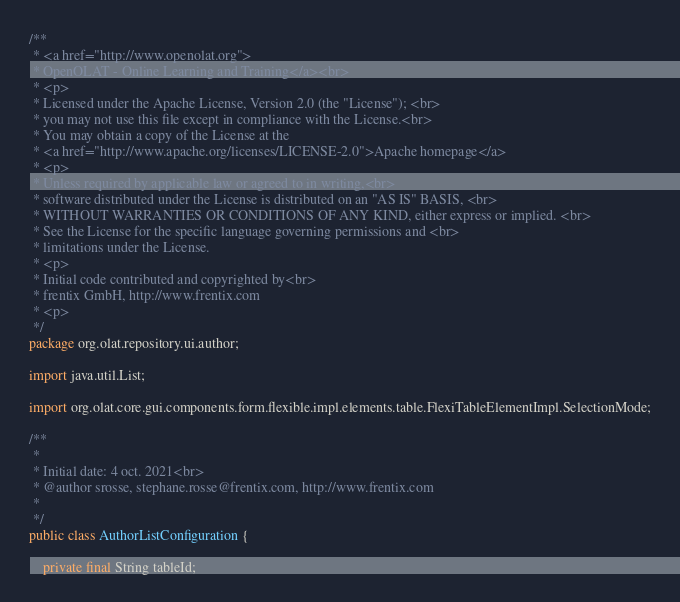Convert code to text. <code><loc_0><loc_0><loc_500><loc_500><_Java_>/**
 * <a href="http://www.openolat.org">
 * OpenOLAT - Online Learning and Training</a><br>
 * <p>
 * Licensed under the Apache License, Version 2.0 (the "License"); <br>
 * you may not use this file except in compliance with the License.<br>
 * You may obtain a copy of the License at the
 * <a href="http://www.apache.org/licenses/LICENSE-2.0">Apache homepage</a>
 * <p>
 * Unless required by applicable law or agreed to in writing,<br>
 * software distributed under the License is distributed on an "AS IS" BASIS, <br>
 * WITHOUT WARRANTIES OR CONDITIONS OF ANY KIND, either express or implied. <br>
 * See the License for the specific language governing permissions and <br>
 * limitations under the License.
 * <p>
 * Initial code contributed and copyrighted by<br>
 * frentix GmbH, http://www.frentix.com
 * <p>
 */
package org.olat.repository.ui.author;

import java.util.List;

import org.olat.core.gui.components.form.flexible.impl.elements.table.FlexiTableElementImpl.SelectionMode;

/**
 * 
 * Initial date: 4 oct. 2021<br>
 * @author srosse, stephane.rosse@frentix.com, http://www.frentix.com
 *
 */
public class AuthorListConfiguration {
	
	private final String tableId;</code> 